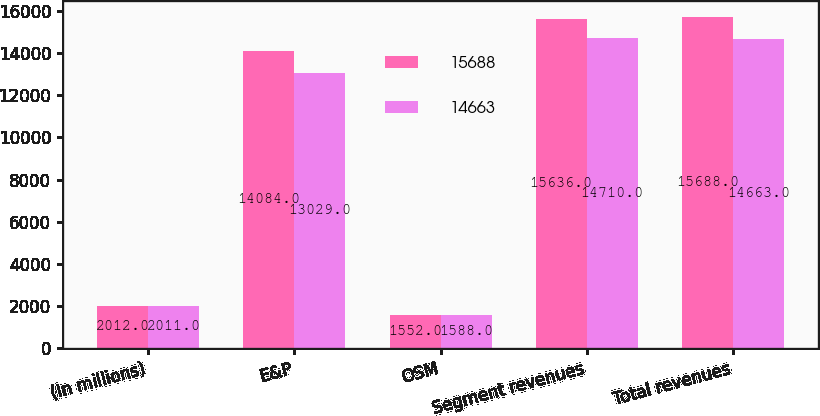Convert chart to OTSL. <chart><loc_0><loc_0><loc_500><loc_500><stacked_bar_chart><ecel><fcel>(In millions)<fcel>E&P<fcel>OSM<fcel>Segment revenues<fcel>Total revenues<nl><fcel>15688<fcel>2012<fcel>14084<fcel>1552<fcel>15636<fcel>15688<nl><fcel>14663<fcel>2011<fcel>13029<fcel>1588<fcel>14710<fcel>14663<nl></chart> 